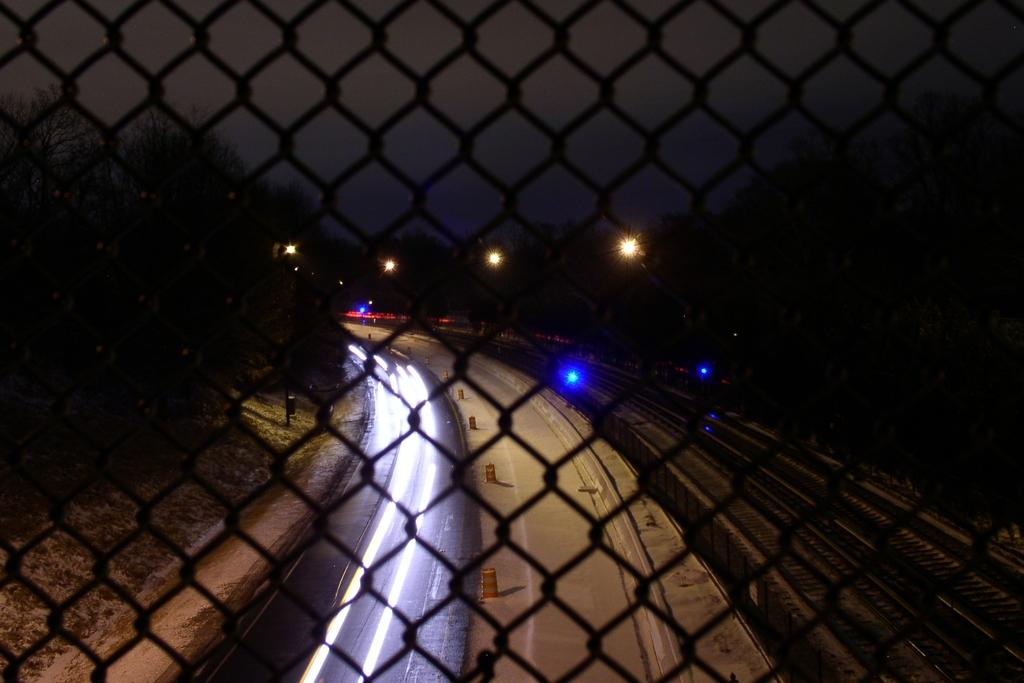What is the main object in the image? There is a grill in the image. What is located at the bottom of the image? There is a road at the bottom of the image. What type of vegetation can be seen on both sides of the image? There are trees on the left and right sides of the image. What is visible at the top of the image? The sky is visible at the top of the image. Reasoning: Let's think step by step by step in order to produce the conversation. We start by identifying the main object in the image, which is the grill. Then, we describe the other elements in the image, such as the road, trees, and sky. Each question is designed to elicit a specific detail about the image that is known from the provided facts. Absurd Question/Answer: What type of cake is being offered in the image? There is no cake present in the image; it features a grill and other outdoor elements. Is there a letter addressed to someone in the image? There is no letter present in the image. What type of cake is being offered in the image? There is no cake present in the image; it features a grill and other outdoor elements. Is there a letter addressed to someone in the image? There is no letter present in the image. 